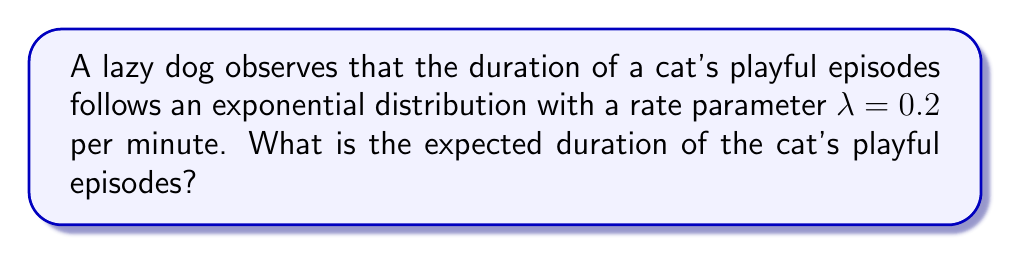Solve this math problem. To solve this problem, we need to follow these steps:

1) Recall that for an exponential distribution with rate parameter $\lambda$, the expected value (mean) is given by:

   $$E[X] = \frac{1}{\lambda}$$

2) We are given that $\lambda = 0.2$ per minute.

3) Substituting this value into the formula:

   $$E[X] = \frac{1}{0.2} = 5$$

4) Therefore, the expected duration of the cat's playful episodes is 5 minutes.

Note: The exponential distribution is often used to model the time between events in a Poisson process, or the lifetime of a system with a constant failure rate. In this case, it's being used to model the duration of a cat's playful episodes, which is a creative application of the concept.
Answer: 5 minutes 